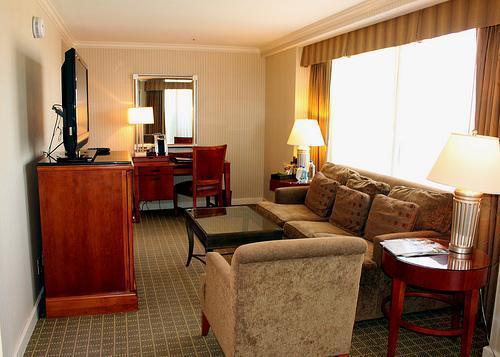How many lamps are there in the image?
Give a very brief answer. 3. 